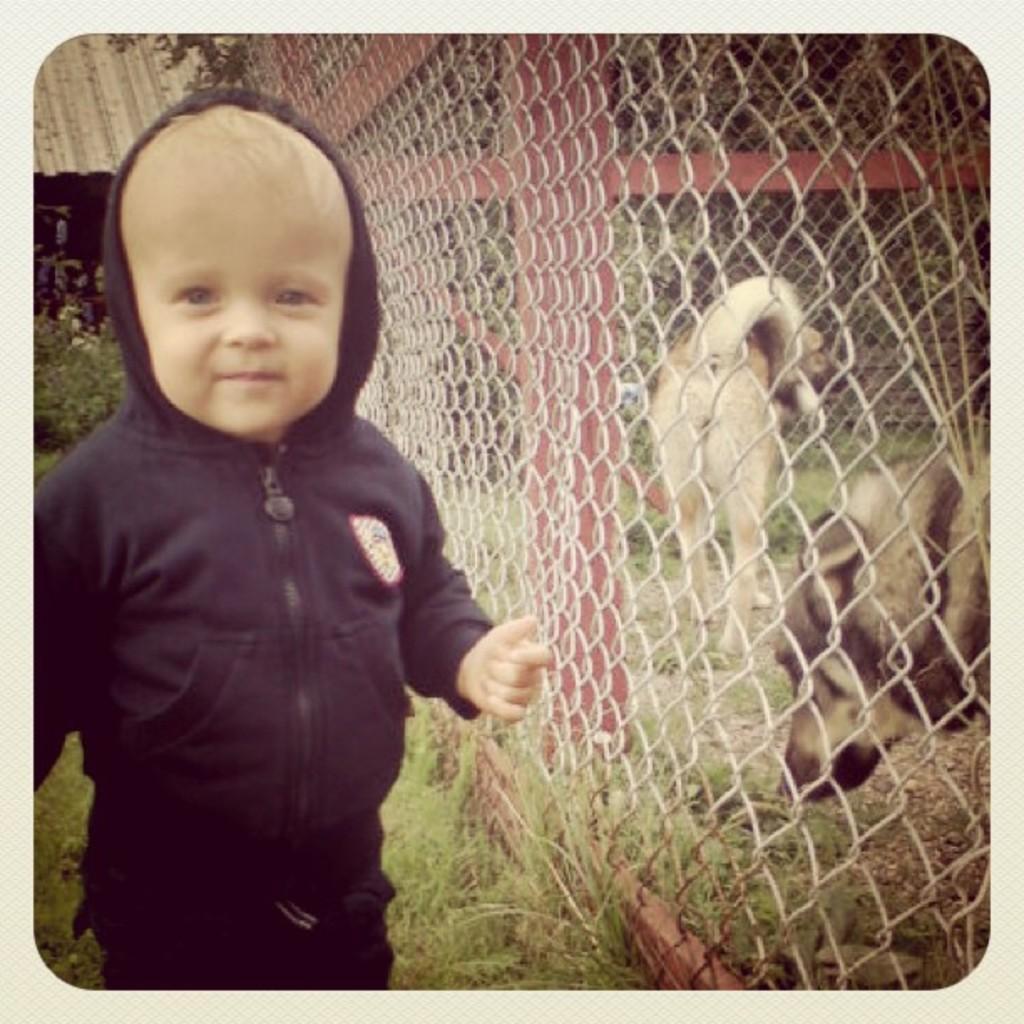Could you give a brief overview of what you see in this image? This is an edited image. On the left side there is a baby wearing a jacket, standing, smiling and giving pose for the picture. On the right side there are two dogs behind the net fencing. In the top left-hand corner there is a roof. In the background there are plants. 